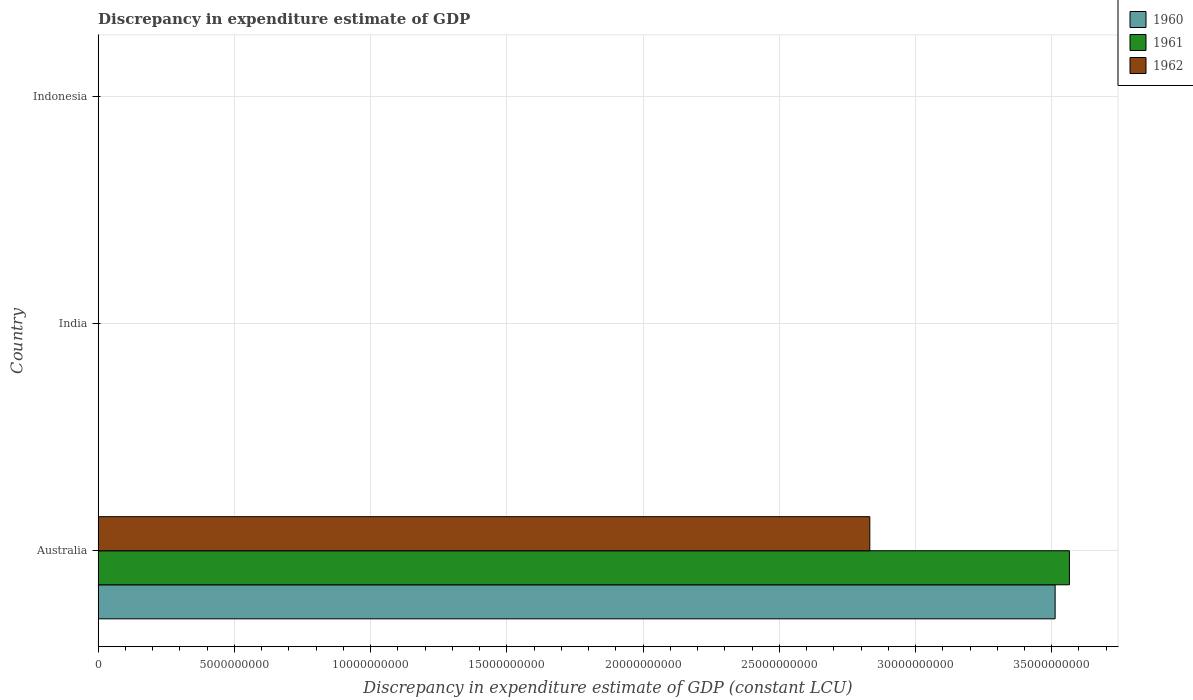Are the number of bars per tick equal to the number of legend labels?
Provide a succinct answer. No. Are the number of bars on each tick of the Y-axis equal?
Your response must be concise. No. How many bars are there on the 2nd tick from the top?
Offer a very short reply. 0. In how many cases, is the number of bars for a given country not equal to the number of legend labels?
Provide a succinct answer. 2. What is the discrepancy in expenditure estimate of GDP in 1960 in India?
Provide a succinct answer. 0. Across all countries, what is the maximum discrepancy in expenditure estimate of GDP in 1962?
Your answer should be very brief. 2.83e+1. Across all countries, what is the minimum discrepancy in expenditure estimate of GDP in 1960?
Offer a terse response. 0. What is the total discrepancy in expenditure estimate of GDP in 1960 in the graph?
Keep it short and to the point. 3.51e+1. What is the average discrepancy in expenditure estimate of GDP in 1961 per country?
Offer a very short reply. 1.19e+1. What is the difference between the discrepancy in expenditure estimate of GDP in 1960 and discrepancy in expenditure estimate of GDP in 1961 in Australia?
Make the answer very short. -5.25e+08. In how many countries, is the discrepancy in expenditure estimate of GDP in 1960 greater than 14000000000 LCU?
Offer a very short reply. 1. What is the difference between the highest and the lowest discrepancy in expenditure estimate of GDP in 1960?
Keep it short and to the point. 3.51e+1. How many bars are there?
Keep it short and to the point. 3. How many countries are there in the graph?
Make the answer very short. 3. Does the graph contain any zero values?
Provide a succinct answer. Yes. Does the graph contain grids?
Provide a short and direct response. Yes. What is the title of the graph?
Ensure brevity in your answer.  Discrepancy in expenditure estimate of GDP. Does "1971" appear as one of the legend labels in the graph?
Offer a terse response. No. What is the label or title of the X-axis?
Your response must be concise. Discrepancy in expenditure estimate of GDP (constant LCU). What is the label or title of the Y-axis?
Keep it short and to the point. Country. What is the Discrepancy in expenditure estimate of GDP (constant LCU) of 1960 in Australia?
Provide a succinct answer. 3.51e+1. What is the Discrepancy in expenditure estimate of GDP (constant LCU) of 1961 in Australia?
Make the answer very short. 3.56e+1. What is the Discrepancy in expenditure estimate of GDP (constant LCU) in 1962 in Australia?
Ensure brevity in your answer.  2.83e+1. What is the Discrepancy in expenditure estimate of GDP (constant LCU) of 1961 in India?
Your response must be concise. 0. Across all countries, what is the maximum Discrepancy in expenditure estimate of GDP (constant LCU) in 1960?
Your answer should be very brief. 3.51e+1. Across all countries, what is the maximum Discrepancy in expenditure estimate of GDP (constant LCU) in 1961?
Make the answer very short. 3.56e+1. Across all countries, what is the maximum Discrepancy in expenditure estimate of GDP (constant LCU) in 1962?
Your answer should be very brief. 2.83e+1. Across all countries, what is the minimum Discrepancy in expenditure estimate of GDP (constant LCU) of 1960?
Provide a short and direct response. 0. Across all countries, what is the minimum Discrepancy in expenditure estimate of GDP (constant LCU) of 1961?
Give a very brief answer. 0. Across all countries, what is the minimum Discrepancy in expenditure estimate of GDP (constant LCU) in 1962?
Your response must be concise. 0. What is the total Discrepancy in expenditure estimate of GDP (constant LCU) in 1960 in the graph?
Keep it short and to the point. 3.51e+1. What is the total Discrepancy in expenditure estimate of GDP (constant LCU) of 1961 in the graph?
Keep it short and to the point. 3.56e+1. What is the total Discrepancy in expenditure estimate of GDP (constant LCU) in 1962 in the graph?
Your answer should be very brief. 2.83e+1. What is the average Discrepancy in expenditure estimate of GDP (constant LCU) in 1960 per country?
Give a very brief answer. 1.17e+1. What is the average Discrepancy in expenditure estimate of GDP (constant LCU) of 1961 per country?
Offer a terse response. 1.19e+1. What is the average Discrepancy in expenditure estimate of GDP (constant LCU) in 1962 per country?
Offer a very short reply. 9.44e+09. What is the difference between the Discrepancy in expenditure estimate of GDP (constant LCU) in 1960 and Discrepancy in expenditure estimate of GDP (constant LCU) in 1961 in Australia?
Provide a succinct answer. -5.25e+08. What is the difference between the Discrepancy in expenditure estimate of GDP (constant LCU) of 1960 and Discrepancy in expenditure estimate of GDP (constant LCU) of 1962 in Australia?
Your answer should be very brief. 6.80e+09. What is the difference between the Discrepancy in expenditure estimate of GDP (constant LCU) in 1961 and Discrepancy in expenditure estimate of GDP (constant LCU) in 1962 in Australia?
Ensure brevity in your answer.  7.33e+09. What is the difference between the highest and the lowest Discrepancy in expenditure estimate of GDP (constant LCU) in 1960?
Offer a very short reply. 3.51e+1. What is the difference between the highest and the lowest Discrepancy in expenditure estimate of GDP (constant LCU) of 1961?
Provide a short and direct response. 3.56e+1. What is the difference between the highest and the lowest Discrepancy in expenditure estimate of GDP (constant LCU) of 1962?
Provide a succinct answer. 2.83e+1. 